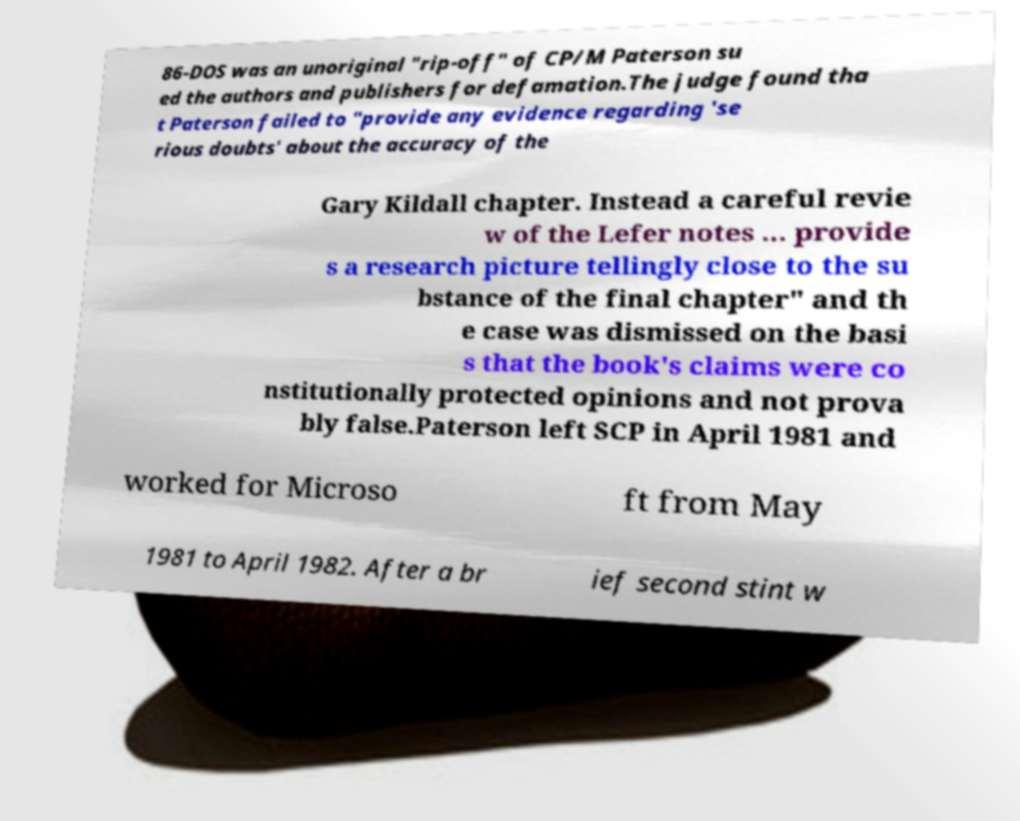Could you assist in decoding the text presented in this image and type it out clearly? 86-DOS was an unoriginal "rip-off" of CP/M Paterson su ed the authors and publishers for defamation.The judge found tha t Paterson failed to "provide any evidence regarding 'se rious doubts' about the accuracy of the Gary Kildall chapter. Instead a careful revie w of the Lefer notes ... provide s a research picture tellingly close to the su bstance of the final chapter" and th e case was dismissed on the basi s that the book's claims were co nstitutionally protected opinions and not prova bly false.Paterson left SCP in April 1981 and worked for Microso ft from May 1981 to April 1982. After a br ief second stint w 